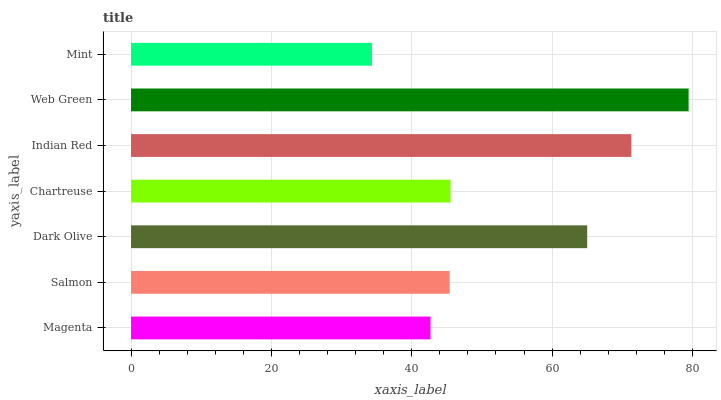Is Mint the minimum?
Answer yes or no. Yes. Is Web Green the maximum?
Answer yes or no. Yes. Is Salmon the minimum?
Answer yes or no. No. Is Salmon the maximum?
Answer yes or no. No. Is Salmon greater than Magenta?
Answer yes or no. Yes. Is Magenta less than Salmon?
Answer yes or no. Yes. Is Magenta greater than Salmon?
Answer yes or no. No. Is Salmon less than Magenta?
Answer yes or no. No. Is Chartreuse the high median?
Answer yes or no. Yes. Is Chartreuse the low median?
Answer yes or no. Yes. Is Magenta the high median?
Answer yes or no. No. Is Indian Red the low median?
Answer yes or no. No. 